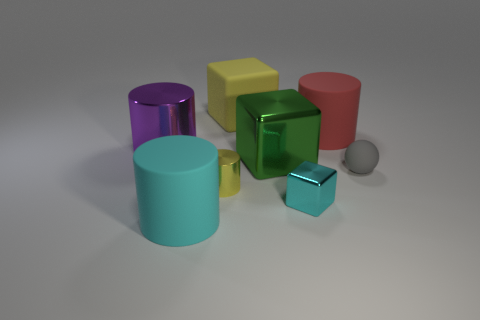The tiny metal cylinder is what color?
Make the answer very short. Yellow. What number of tiny objects are purple metal objects or cyan metallic things?
Your response must be concise. 1. There is a thing that is the same color as the small cube; what material is it?
Keep it short and to the point. Rubber. Does the cube to the left of the large green cube have the same material as the yellow cylinder that is right of the purple shiny cylinder?
Provide a succinct answer. No. Is there a object?
Ensure brevity in your answer.  Yes. Are there more tiny metal cubes to the left of the big metal cylinder than green shiny cubes in front of the tiny gray object?
Ensure brevity in your answer.  No. There is another big thing that is the same shape as the green shiny object; what is its material?
Make the answer very short. Rubber. Is there any other thing that is the same size as the red rubber thing?
Your answer should be compact. Yes. There is a large object in front of the small cylinder; is its color the same as the rubber cylinder right of the cyan block?
Your response must be concise. No. There is a gray thing; what shape is it?
Provide a succinct answer. Sphere. 